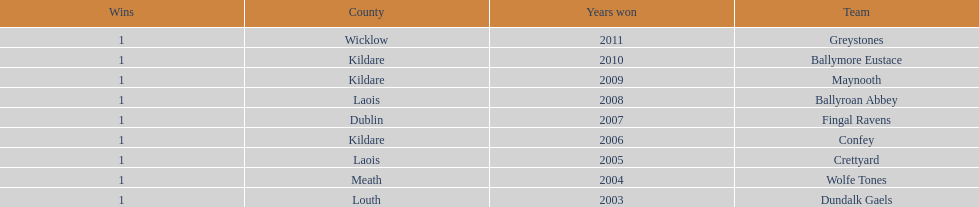What is the last team on the chart Dundalk Gaels. 